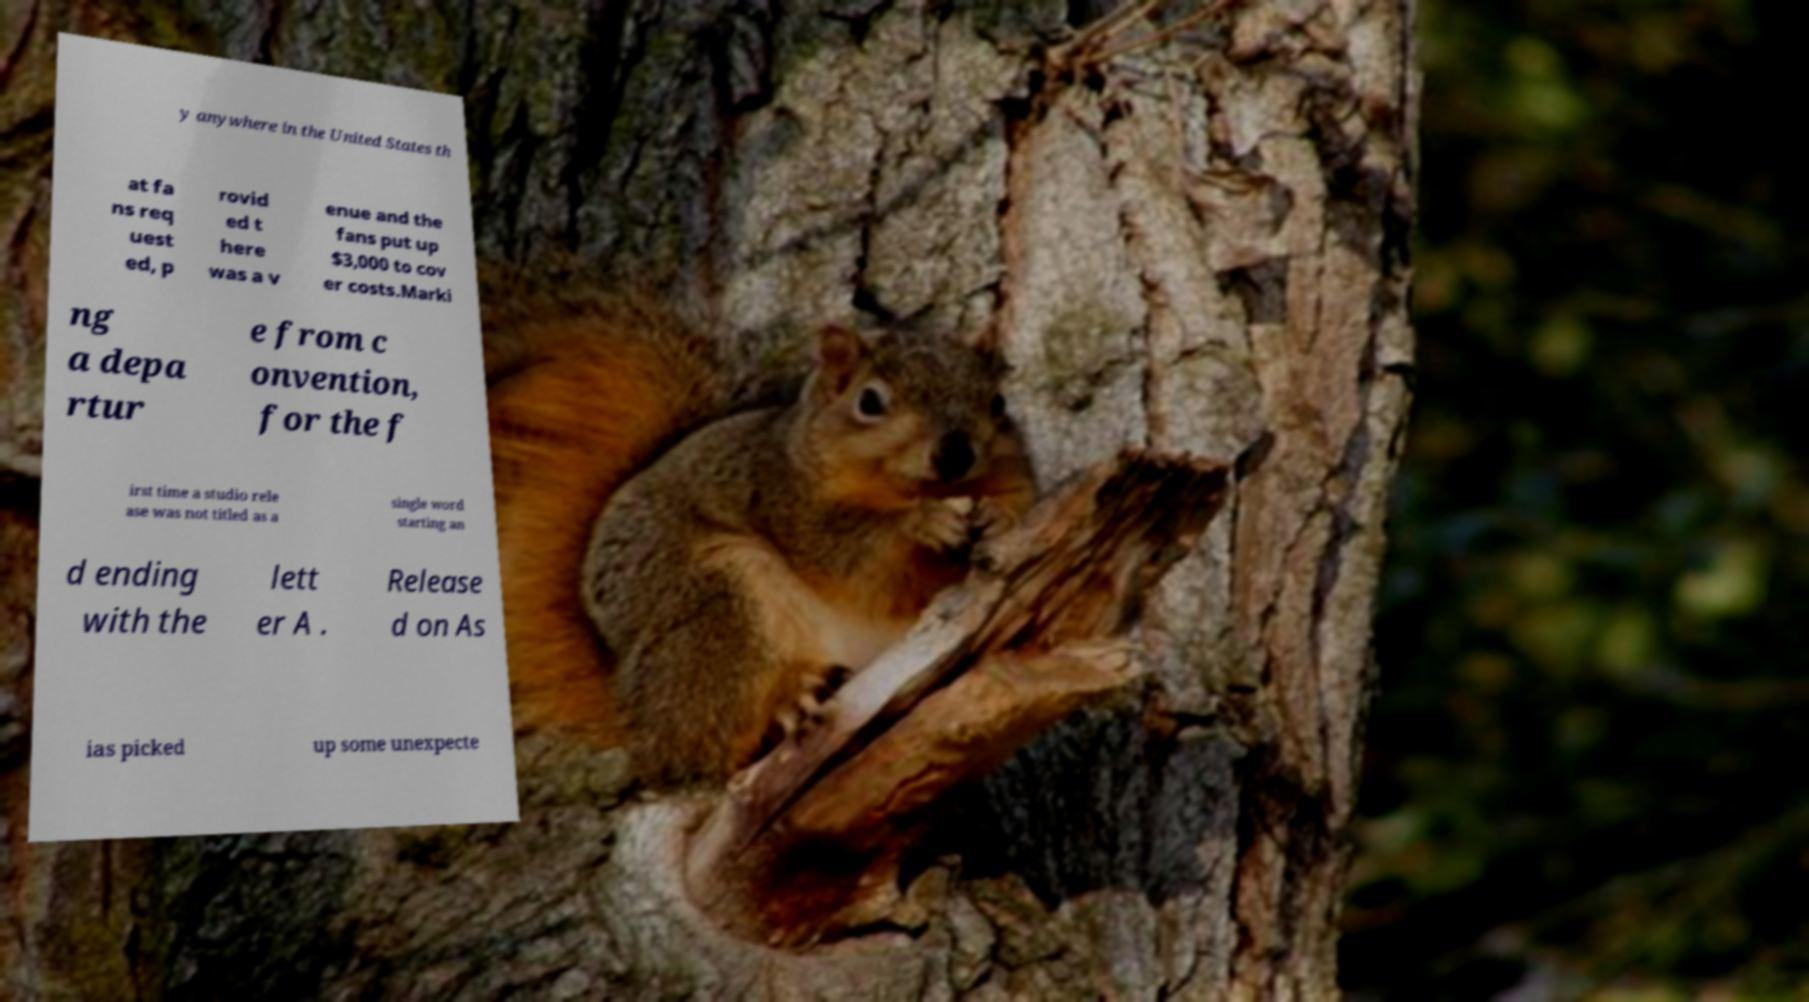Can you read and provide the text displayed in the image?This photo seems to have some interesting text. Can you extract and type it out for me? y anywhere in the United States th at fa ns req uest ed, p rovid ed t here was a v enue and the fans put up $3,000 to cov er costs.Marki ng a depa rtur e from c onvention, for the f irst time a studio rele ase was not titled as a single word starting an d ending with the lett er A . Release d on As ias picked up some unexpecte 